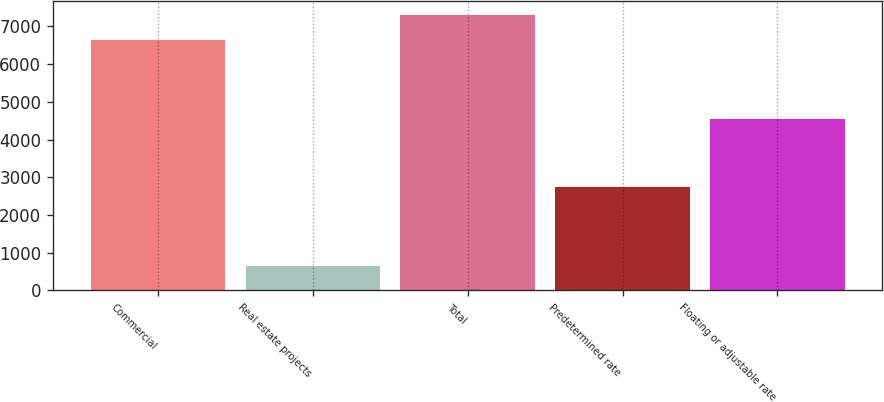Convert chart. <chart><loc_0><loc_0><loc_500><loc_500><bar_chart><fcel>Commercial<fcel>Real estate projects<fcel>Total<fcel>Predetermined rate<fcel>Floating or adjustable rate<nl><fcel>6638<fcel>655<fcel>7301.8<fcel>2754<fcel>4539<nl></chart> 